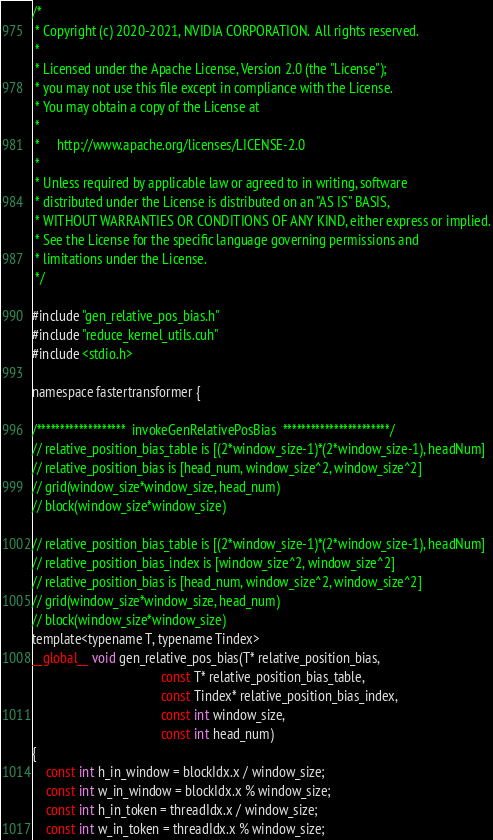Convert code to text. <code><loc_0><loc_0><loc_500><loc_500><_Cuda_>/*
 * Copyright (c) 2020-2021, NVIDIA CORPORATION.  All rights reserved.
 *
 * Licensed under the Apache License, Version 2.0 (the "License");
 * you may not use this file except in compliance with the License.
 * You may obtain a copy of the License at
 *
 *     http://www.apache.org/licenses/LICENSE-2.0
 *
 * Unless required by applicable law or agreed to in writing, software
 * distributed under the License is distributed on an "AS IS" BASIS,
 * WITHOUT WARRANTIES OR CONDITIONS OF ANY KIND, either express or implied.
 * See the License for the specific language governing permissions and
 * limitations under the License.
 */

#include "gen_relative_pos_bias.h"
#include "reduce_kernel_utils.cuh"
#include <stdio.h>

namespace fastertransformer {

/*******************  invokeGenRelativePosBias  ***********************/
// relative_position_bias_table is [(2*window_size-1)*(2*window_size-1), headNum]
// relative_position_bias is [head_num, window_size^2, window_size^2]
// grid(window_size*window_size, head_num)
// block(window_size*window_size)

// relative_position_bias_table is [(2*window_size-1)*(2*window_size-1), headNum]
// relative_position_bias_index is [window_size^2, window_size^2]
// relative_position_bias is [head_num, window_size^2, window_size^2]
// grid(window_size*window_size, head_num)
// block(window_size*window_size)
template<typename T, typename Tindex>
__global__ void gen_relative_pos_bias(T* relative_position_bias,
                                      const T* relative_position_bias_table,
                                      const Tindex* relative_position_bias_index,
                                      const int window_size,
                                      const int head_num)
{
    const int h_in_window = blockIdx.x / window_size;
    const int w_in_window = blockIdx.x % window_size;
    const int h_in_token = threadIdx.x / window_size;
    const int w_in_token = threadIdx.x % window_size;</code> 